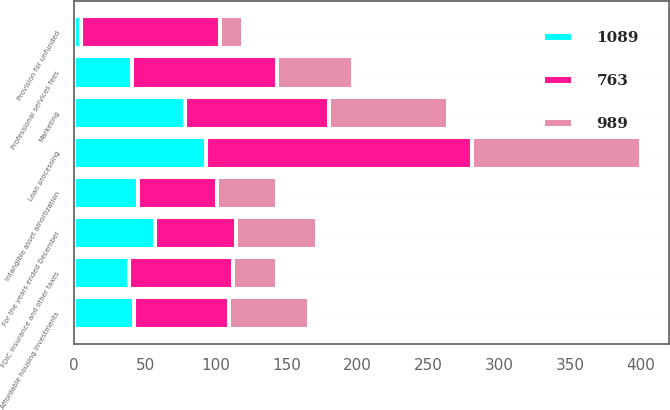Convert chart. <chart><loc_0><loc_0><loc_500><loc_500><stacked_bar_chart><ecel><fcel>For the years ended December<fcel>Loan processing<fcel>Marketing<fcel>Professional services fees<fcel>Provision for unfunded<fcel>FDIC insurance and other taxes<fcel>Affordable housing investments<fcel>Intangible asset amortization<nl><fcel>763<fcel>57<fcel>188<fcel>102<fcel>102<fcel>98<fcel>73<fcel>67<fcel>56<nl><fcel>989<fcel>57<fcel>119<fcel>84<fcel>54<fcel>16<fcel>31<fcel>57<fcel>42<nl><fcel>1089<fcel>57<fcel>93<fcel>78<fcel>41<fcel>5<fcel>39<fcel>42<fcel>45<nl></chart> 